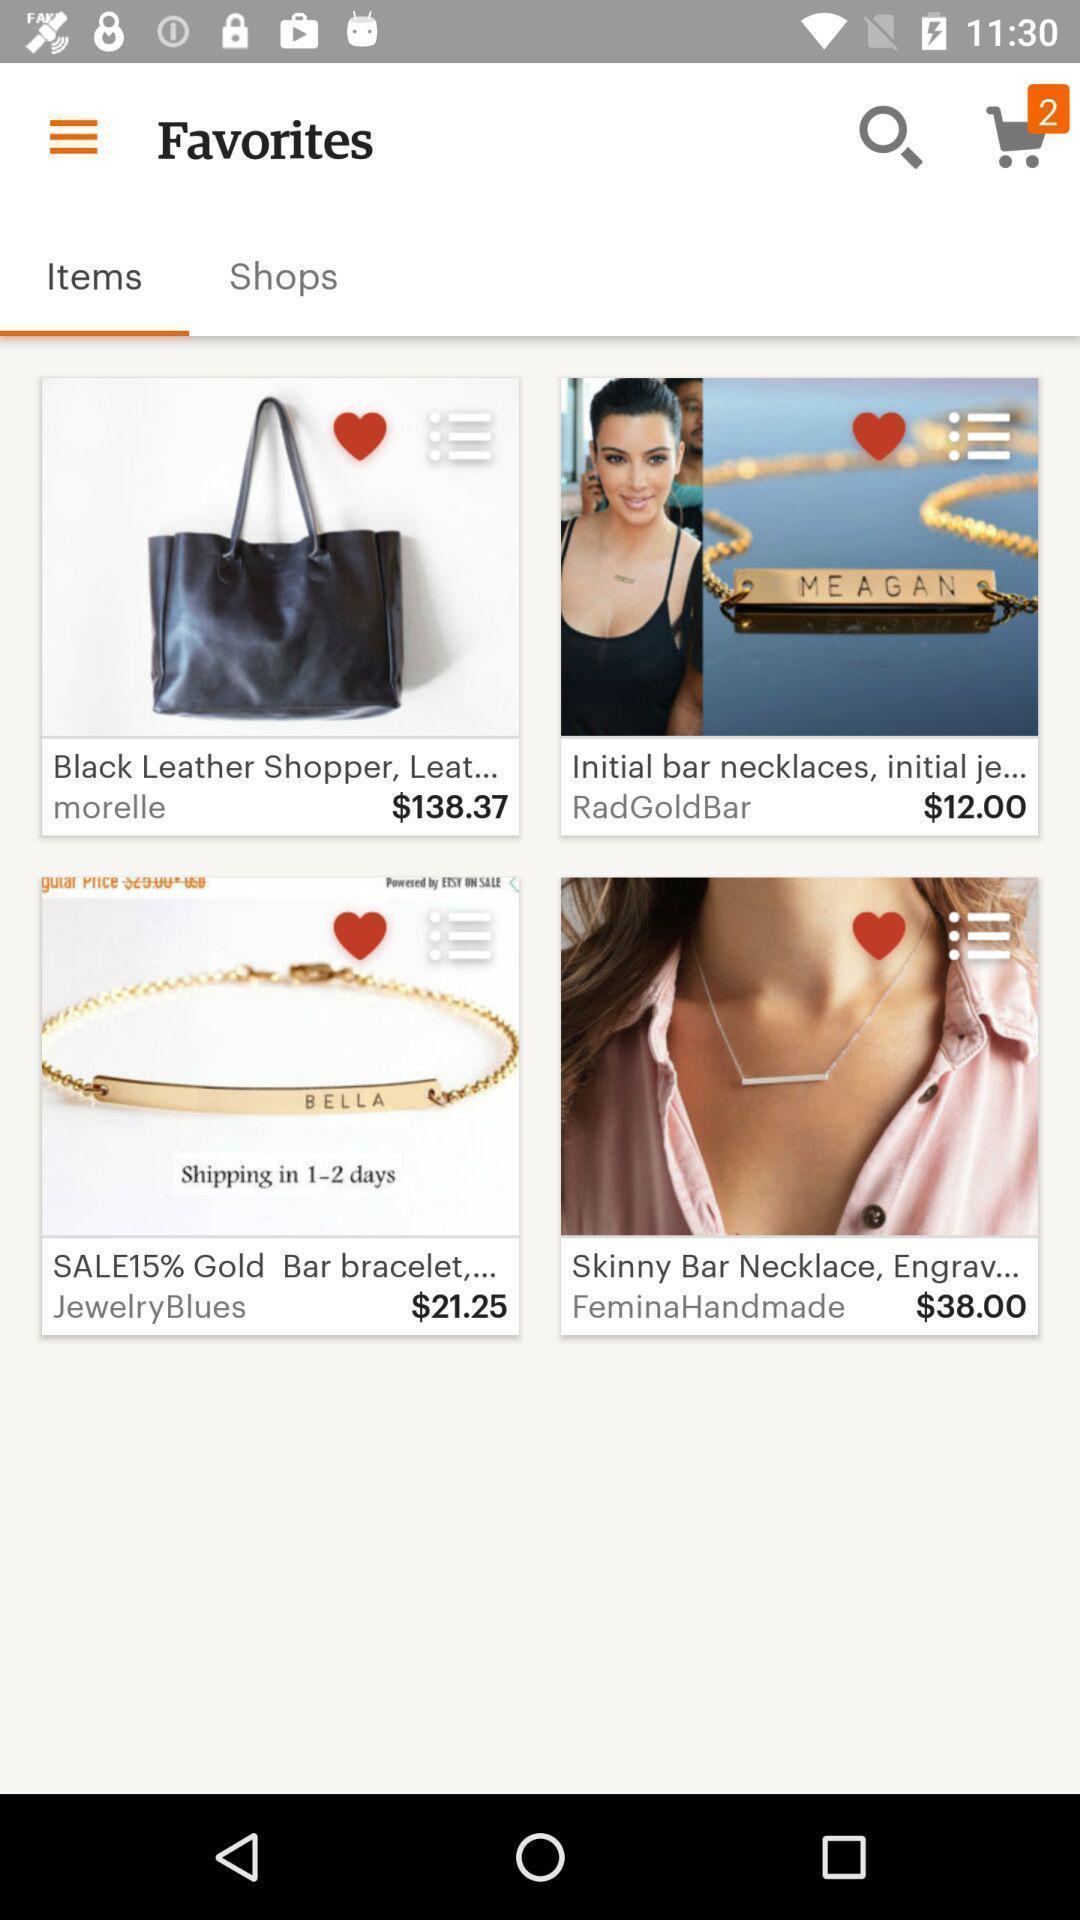Explain the elements present in this screenshot. Page showing the items in favorites. 